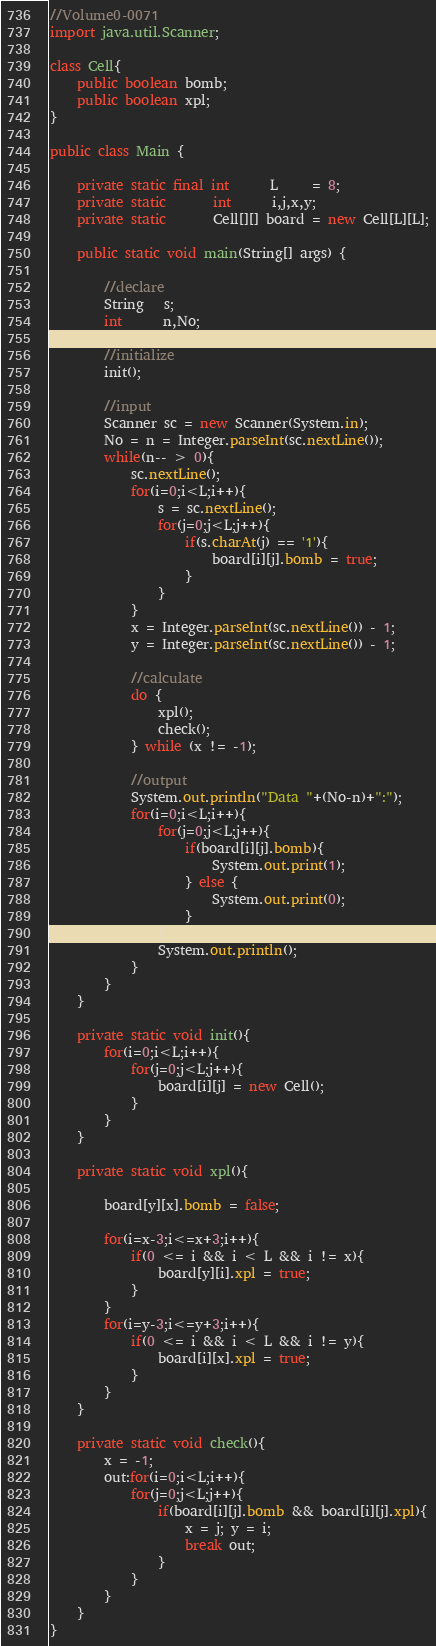<code> <loc_0><loc_0><loc_500><loc_500><_Java_>//Volume0-0071
import java.util.Scanner;

class Cell{
	public boolean bomb;
	public boolean xpl;
}

public class Main {

	private static final int      L     = 8;
	private static       int      i,j,x,y;
    private static       Cell[][] board = new Cell[L][L];

	public static void main(String[] args) {

		//declare
		String   s;
		int      n,No;

		//initialize
		init();

        //input
        Scanner sc = new Scanner(System.in);
        No = n = Integer.parseInt(sc.nextLine());
        while(n-- > 0){
        	sc.nextLine();
        	for(i=0;i<L;i++){
        		s = sc.nextLine();
        		for(j=0;j<L;j++){
        			if(s.charAt(j) == '1'){
        				board[i][j].bomb = true;
        			}
        		}
        	}
        	x = Integer.parseInt(sc.nextLine()) - 1;
        	y = Integer.parseInt(sc.nextLine()) - 1;

        	//calculate
        	do {
        		xpl();
        		check();
        	} while (x != -1);

        	//output
        	System.out.println("Data "+(No-n)+":");
        	for(i=0;i<L;i++){
        		for(j=0;j<L;j++){
        			if(board[i][j].bomb){
        				System.out.print(1);
        			} else {
        				System.out.print(0);
        			}
        		}
        		System.out.println();
        	}
        }
	}

	private static void init(){
		for(i=0;i<L;i++){
			for(j=0;j<L;j++){
				board[i][j] = new Cell();
			}
		}
	}

	private static void xpl(){

		board[y][x].bomb = false;

		for(i=x-3;i<=x+3;i++){
			if(0 <= i && i < L && i != x){
				board[y][i].xpl = true;
			}
		}
		for(i=y-3;i<=y+3;i++){
			if(0 <= i && i < L && i != y){
				board[i][x].xpl = true;
			}
		}
	}

	private static void check(){
		x = -1;
		out:for(i=0;i<L;i++){
			for(j=0;j<L;j++){
				if(board[i][j].bomb && board[i][j].xpl){
					x = j; y = i;
					break out;
				}
			}
		}
	}
}</code> 